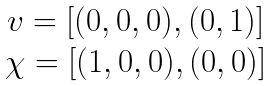Convert formula to latex. <formula><loc_0><loc_0><loc_500><loc_500>\begin{array} { c } v = [ ( 0 , 0 , 0 ) , ( 0 , 1 ) ] \\ \chi = [ ( 1 , 0 , 0 ) , ( 0 , 0 ) ] \end{array}</formula> 